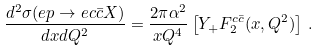<formula> <loc_0><loc_0><loc_500><loc_500>\frac { d ^ { 2 } \sigma ( e p \rightarrow e c \bar { c } X ) } { d x d Q ^ { 2 } } = \frac { 2 \pi \alpha ^ { 2 } } { x Q ^ { 4 } } \left [ Y _ { + } F _ { 2 } ^ { c \bar { c } } ( x , Q ^ { 2 } ) \right ] \, .</formula> 